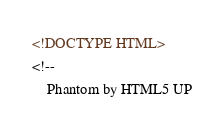Convert code to text. <code><loc_0><loc_0><loc_500><loc_500><_HTML_><!DOCTYPE HTML>
<!--
	Phantom by HTML5 UP</code> 